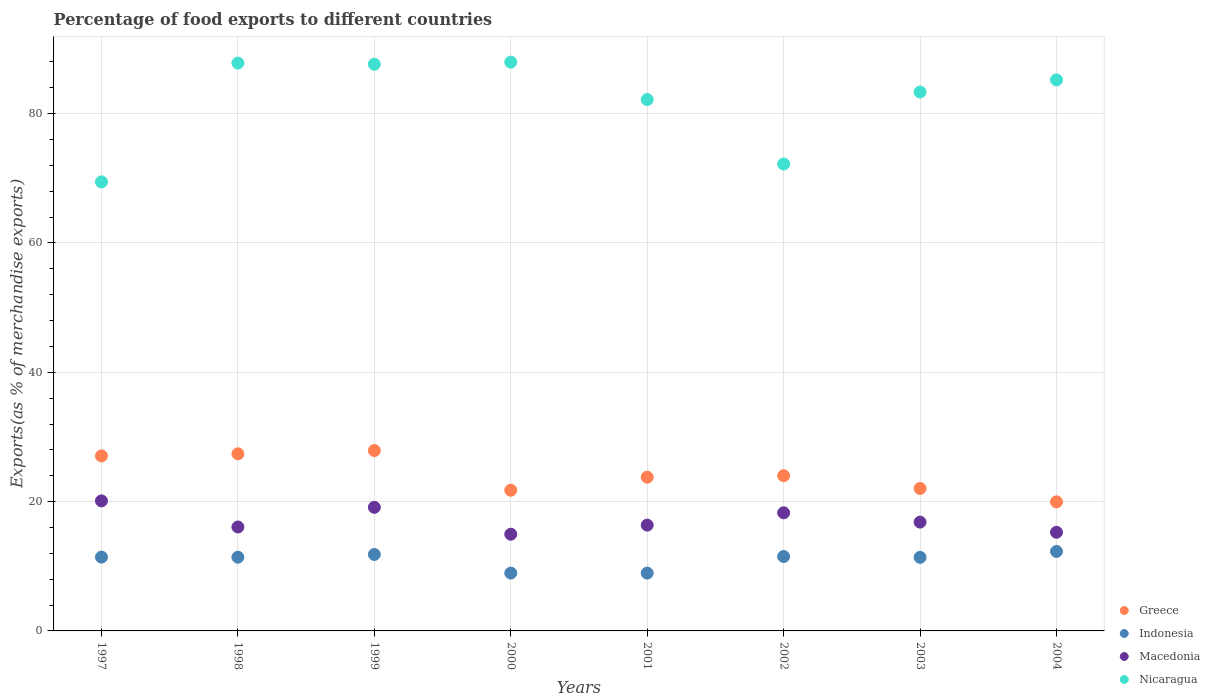How many different coloured dotlines are there?
Offer a terse response. 4. What is the percentage of exports to different countries in Indonesia in 2002?
Make the answer very short. 11.51. Across all years, what is the maximum percentage of exports to different countries in Indonesia?
Give a very brief answer. 12.29. Across all years, what is the minimum percentage of exports to different countries in Macedonia?
Your answer should be very brief. 14.96. In which year was the percentage of exports to different countries in Greece minimum?
Ensure brevity in your answer.  2004. What is the total percentage of exports to different countries in Indonesia in the graph?
Provide a short and direct response. 87.72. What is the difference between the percentage of exports to different countries in Nicaragua in 1997 and that in 2000?
Offer a very short reply. -18.52. What is the difference between the percentage of exports to different countries in Indonesia in 2002 and the percentage of exports to different countries in Greece in 2001?
Offer a terse response. -12.27. What is the average percentage of exports to different countries in Indonesia per year?
Ensure brevity in your answer.  10.97. In the year 1997, what is the difference between the percentage of exports to different countries in Nicaragua and percentage of exports to different countries in Macedonia?
Make the answer very short. 49.34. In how many years, is the percentage of exports to different countries in Indonesia greater than 16 %?
Your answer should be compact. 0. What is the ratio of the percentage of exports to different countries in Nicaragua in 1999 to that in 2003?
Your response must be concise. 1.05. Is the percentage of exports to different countries in Nicaragua in 1999 less than that in 2002?
Offer a terse response. No. Is the difference between the percentage of exports to different countries in Nicaragua in 2000 and 2003 greater than the difference between the percentage of exports to different countries in Macedonia in 2000 and 2003?
Offer a very short reply. Yes. What is the difference between the highest and the second highest percentage of exports to different countries in Indonesia?
Your answer should be compact. 0.46. What is the difference between the highest and the lowest percentage of exports to different countries in Greece?
Make the answer very short. 7.93. Is it the case that in every year, the sum of the percentage of exports to different countries in Macedonia and percentage of exports to different countries in Nicaragua  is greater than the percentage of exports to different countries in Greece?
Your answer should be compact. Yes. How many years are there in the graph?
Your answer should be compact. 8. What is the difference between two consecutive major ticks on the Y-axis?
Make the answer very short. 20. Are the values on the major ticks of Y-axis written in scientific E-notation?
Your response must be concise. No. Does the graph contain any zero values?
Offer a very short reply. No. Does the graph contain grids?
Ensure brevity in your answer.  Yes. How many legend labels are there?
Keep it short and to the point. 4. What is the title of the graph?
Your answer should be compact. Percentage of food exports to different countries. Does "Cameroon" appear as one of the legend labels in the graph?
Make the answer very short. No. What is the label or title of the Y-axis?
Provide a short and direct response. Exports(as % of merchandise exports). What is the Exports(as % of merchandise exports) in Greece in 1997?
Provide a short and direct response. 27.07. What is the Exports(as % of merchandise exports) of Indonesia in 1997?
Your answer should be very brief. 11.42. What is the Exports(as % of merchandise exports) of Macedonia in 1997?
Ensure brevity in your answer.  20.11. What is the Exports(as % of merchandise exports) of Nicaragua in 1997?
Give a very brief answer. 69.45. What is the Exports(as % of merchandise exports) of Greece in 1998?
Provide a succinct answer. 27.4. What is the Exports(as % of merchandise exports) of Indonesia in 1998?
Your response must be concise. 11.4. What is the Exports(as % of merchandise exports) of Macedonia in 1998?
Offer a terse response. 16.08. What is the Exports(as % of merchandise exports) in Nicaragua in 1998?
Ensure brevity in your answer.  87.83. What is the Exports(as % of merchandise exports) of Greece in 1999?
Offer a very short reply. 27.9. What is the Exports(as % of merchandise exports) in Indonesia in 1999?
Keep it short and to the point. 11.83. What is the Exports(as % of merchandise exports) of Macedonia in 1999?
Ensure brevity in your answer.  19.12. What is the Exports(as % of merchandise exports) in Nicaragua in 1999?
Provide a succinct answer. 87.65. What is the Exports(as % of merchandise exports) in Greece in 2000?
Give a very brief answer. 21.76. What is the Exports(as % of merchandise exports) of Indonesia in 2000?
Provide a short and direct response. 8.95. What is the Exports(as % of merchandise exports) of Macedonia in 2000?
Make the answer very short. 14.96. What is the Exports(as % of merchandise exports) of Nicaragua in 2000?
Offer a very short reply. 87.98. What is the Exports(as % of merchandise exports) in Greece in 2001?
Offer a very short reply. 23.78. What is the Exports(as % of merchandise exports) of Indonesia in 2001?
Offer a very short reply. 8.95. What is the Exports(as % of merchandise exports) in Macedonia in 2001?
Your response must be concise. 16.37. What is the Exports(as % of merchandise exports) of Nicaragua in 2001?
Offer a terse response. 82.19. What is the Exports(as % of merchandise exports) of Greece in 2002?
Your answer should be compact. 24.01. What is the Exports(as % of merchandise exports) in Indonesia in 2002?
Make the answer very short. 11.51. What is the Exports(as % of merchandise exports) in Macedonia in 2002?
Your response must be concise. 18.27. What is the Exports(as % of merchandise exports) in Nicaragua in 2002?
Offer a very short reply. 72.21. What is the Exports(as % of merchandise exports) in Greece in 2003?
Your answer should be compact. 22.03. What is the Exports(as % of merchandise exports) in Indonesia in 2003?
Provide a succinct answer. 11.38. What is the Exports(as % of merchandise exports) in Macedonia in 2003?
Make the answer very short. 16.83. What is the Exports(as % of merchandise exports) of Nicaragua in 2003?
Give a very brief answer. 83.35. What is the Exports(as % of merchandise exports) of Greece in 2004?
Provide a short and direct response. 19.96. What is the Exports(as % of merchandise exports) in Indonesia in 2004?
Give a very brief answer. 12.29. What is the Exports(as % of merchandise exports) of Macedonia in 2004?
Your answer should be compact. 15.26. What is the Exports(as % of merchandise exports) of Nicaragua in 2004?
Make the answer very short. 85.23. Across all years, what is the maximum Exports(as % of merchandise exports) of Greece?
Offer a terse response. 27.9. Across all years, what is the maximum Exports(as % of merchandise exports) of Indonesia?
Your answer should be very brief. 12.29. Across all years, what is the maximum Exports(as % of merchandise exports) in Macedonia?
Your answer should be very brief. 20.11. Across all years, what is the maximum Exports(as % of merchandise exports) in Nicaragua?
Give a very brief answer. 87.98. Across all years, what is the minimum Exports(as % of merchandise exports) in Greece?
Provide a short and direct response. 19.96. Across all years, what is the minimum Exports(as % of merchandise exports) of Indonesia?
Make the answer very short. 8.95. Across all years, what is the minimum Exports(as % of merchandise exports) of Macedonia?
Your response must be concise. 14.96. Across all years, what is the minimum Exports(as % of merchandise exports) in Nicaragua?
Provide a succinct answer. 69.45. What is the total Exports(as % of merchandise exports) of Greece in the graph?
Give a very brief answer. 193.91. What is the total Exports(as % of merchandise exports) of Indonesia in the graph?
Keep it short and to the point. 87.72. What is the total Exports(as % of merchandise exports) of Macedonia in the graph?
Give a very brief answer. 136.99. What is the total Exports(as % of merchandise exports) of Nicaragua in the graph?
Give a very brief answer. 655.89. What is the difference between the Exports(as % of merchandise exports) of Greece in 1997 and that in 1998?
Offer a very short reply. -0.33. What is the difference between the Exports(as % of merchandise exports) in Indonesia in 1997 and that in 1998?
Make the answer very short. 0.01. What is the difference between the Exports(as % of merchandise exports) of Macedonia in 1997 and that in 1998?
Offer a terse response. 4.04. What is the difference between the Exports(as % of merchandise exports) in Nicaragua in 1997 and that in 1998?
Give a very brief answer. -18.38. What is the difference between the Exports(as % of merchandise exports) in Greece in 1997 and that in 1999?
Your answer should be compact. -0.83. What is the difference between the Exports(as % of merchandise exports) of Indonesia in 1997 and that in 1999?
Your answer should be compact. -0.41. What is the difference between the Exports(as % of merchandise exports) in Nicaragua in 1997 and that in 1999?
Keep it short and to the point. -18.2. What is the difference between the Exports(as % of merchandise exports) of Greece in 1997 and that in 2000?
Give a very brief answer. 5.3. What is the difference between the Exports(as % of merchandise exports) of Indonesia in 1997 and that in 2000?
Offer a terse response. 2.47. What is the difference between the Exports(as % of merchandise exports) in Macedonia in 1997 and that in 2000?
Your answer should be compact. 5.15. What is the difference between the Exports(as % of merchandise exports) of Nicaragua in 1997 and that in 2000?
Make the answer very short. -18.52. What is the difference between the Exports(as % of merchandise exports) of Greece in 1997 and that in 2001?
Your answer should be compact. 3.29. What is the difference between the Exports(as % of merchandise exports) of Indonesia in 1997 and that in 2001?
Keep it short and to the point. 2.47. What is the difference between the Exports(as % of merchandise exports) in Macedonia in 1997 and that in 2001?
Offer a very short reply. 3.75. What is the difference between the Exports(as % of merchandise exports) in Nicaragua in 1997 and that in 2001?
Give a very brief answer. -12.73. What is the difference between the Exports(as % of merchandise exports) of Greece in 1997 and that in 2002?
Make the answer very short. 3.06. What is the difference between the Exports(as % of merchandise exports) in Indonesia in 1997 and that in 2002?
Your answer should be very brief. -0.09. What is the difference between the Exports(as % of merchandise exports) of Macedonia in 1997 and that in 2002?
Give a very brief answer. 1.84. What is the difference between the Exports(as % of merchandise exports) of Nicaragua in 1997 and that in 2002?
Your answer should be compact. -2.76. What is the difference between the Exports(as % of merchandise exports) in Greece in 1997 and that in 2003?
Your response must be concise. 5.03. What is the difference between the Exports(as % of merchandise exports) in Indonesia in 1997 and that in 2003?
Your response must be concise. 0.04. What is the difference between the Exports(as % of merchandise exports) in Macedonia in 1997 and that in 2003?
Give a very brief answer. 3.28. What is the difference between the Exports(as % of merchandise exports) in Nicaragua in 1997 and that in 2003?
Offer a terse response. -13.9. What is the difference between the Exports(as % of merchandise exports) of Greece in 1997 and that in 2004?
Your answer should be compact. 7.1. What is the difference between the Exports(as % of merchandise exports) in Indonesia in 1997 and that in 2004?
Give a very brief answer. -0.87. What is the difference between the Exports(as % of merchandise exports) of Macedonia in 1997 and that in 2004?
Your response must be concise. 4.85. What is the difference between the Exports(as % of merchandise exports) in Nicaragua in 1997 and that in 2004?
Offer a very short reply. -15.78. What is the difference between the Exports(as % of merchandise exports) in Greece in 1998 and that in 1999?
Make the answer very short. -0.5. What is the difference between the Exports(as % of merchandise exports) in Indonesia in 1998 and that in 1999?
Provide a succinct answer. -0.43. What is the difference between the Exports(as % of merchandise exports) in Macedonia in 1998 and that in 1999?
Ensure brevity in your answer.  -3.04. What is the difference between the Exports(as % of merchandise exports) in Nicaragua in 1998 and that in 1999?
Ensure brevity in your answer.  0.18. What is the difference between the Exports(as % of merchandise exports) of Greece in 1998 and that in 2000?
Your answer should be compact. 5.63. What is the difference between the Exports(as % of merchandise exports) of Indonesia in 1998 and that in 2000?
Offer a very short reply. 2.46. What is the difference between the Exports(as % of merchandise exports) in Macedonia in 1998 and that in 2000?
Offer a very short reply. 1.12. What is the difference between the Exports(as % of merchandise exports) of Nicaragua in 1998 and that in 2000?
Offer a very short reply. -0.14. What is the difference between the Exports(as % of merchandise exports) of Greece in 1998 and that in 2001?
Ensure brevity in your answer.  3.62. What is the difference between the Exports(as % of merchandise exports) of Indonesia in 1998 and that in 2001?
Offer a very short reply. 2.46. What is the difference between the Exports(as % of merchandise exports) of Macedonia in 1998 and that in 2001?
Provide a short and direct response. -0.29. What is the difference between the Exports(as % of merchandise exports) of Nicaragua in 1998 and that in 2001?
Keep it short and to the point. 5.65. What is the difference between the Exports(as % of merchandise exports) in Greece in 1998 and that in 2002?
Provide a short and direct response. 3.39. What is the difference between the Exports(as % of merchandise exports) in Indonesia in 1998 and that in 2002?
Ensure brevity in your answer.  -0.11. What is the difference between the Exports(as % of merchandise exports) of Macedonia in 1998 and that in 2002?
Your answer should be very brief. -2.2. What is the difference between the Exports(as % of merchandise exports) in Nicaragua in 1998 and that in 2002?
Your answer should be very brief. 15.62. What is the difference between the Exports(as % of merchandise exports) of Greece in 1998 and that in 2003?
Your response must be concise. 5.36. What is the difference between the Exports(as % of merchandise exports) in Indonesia in 1998 and that in 2003?
Provide a short and direct response. 0.02. What is the difference between the Exports(as % of merchandise exports) in Macedonia in 1998 and that in 2003?
Provide a succinct answer. -0.75. What is the difference between the Exports(as % of merchandise exports) in Nicaragua in 1998 and that in 2003?
Ensure brevity in your answer.  4.48. What is the difference between the Exports(as % of merchandise exports) of Greece in 1998 and that in 2004?
Keep it short and to the point. 7.43. What is the difference between the Exports(as % of merchandise exports) in Indonesia in 1998 and that in 2004?
Your answer should be very brief. -0.89. What is the difference between the Exports(as % of merchandise exports) in Macedonia in 1998 and that in 2004?
Your response must be concise. 0.82. What is the difference between the Exports(as % of merchandise exports) in Nicaragua in 1998 and that in 2004?
Make the answer very short. 2.6. What is the difference between the Exports(as % of merchandise exports) of Greece in 1999 and that in 2000?
Ensure brevity in your answer.  6.13. What is the difference between the Exports(as % of merchandise exports) of Indonesia in 1999 and that in 2000?
Your answer should be very brief. 2.88. What is the difference between the Exports(as % of merchandise exports) in Macedonia in 1999 and that in 2000?
Keep it short and to the point. 4.16. What is the difference between the Exports(as % of merchandise exports) of Nicaragua in 1999 and that in 2000?
Keep it short and to the point. -0.32. What is the difference between the Exports(as % of merchandise exports) in Greece in 1999 and that in 2001?
Your answer should be very brief. 4.12. What is the difference between the Exports(as % of merchandise exports) of Indonesia in 1999 and that in 2001?
Provide a short and direct response. 2.88. What is the difference between the Exports(as % of merchandise exports) in Macedonia in 1999 and that in 2001?
Offer a terse response. 2.75. What is the difference between the Exports(as % of merchandise exports) of Nicaragua in 1999 and that in 2001?
Your answer should be compact. 5.47. What is the difference between the Exports(as % of merchandise exports) of Greece in 1999 and that in 2002?
Offer a terse response. 3.89. What is the difference between the Exports(as % of merchandise exports) of Indonesia in 1999 and that in 2002?
Offer a very short reply. 0.32. What is the difference between the Exports(as % of merchandise exports) in Macedonia in 1999 and that in 2002?
Ensure brevity in your answer.  0.85. What is the difference between the Exports(as % of merchandise exports) in Nicaragua in 1999 and that in 2002?
Your answer should be compact. 15.44. What is the difference between the Exports(as % of merchandise exports) in Greece in 1999 and that in 2003?
Your answer should be compact. 5.86. What is the difference between the Exports(as % of merchandise exports) in Indonesia in 1999 and that in 2003?
Ensure brevity in your answer.  0.45. What is the difference between the Exports(as % of merchandise exports) of Macedonia in 1999 and that in 2003?
Provide a succinct answer. 2.29. What is the difference between the Exports(as % of merchandise exports) in Nicaragua in 1999 and that in 2003?
Provide a succinct answer. 4.3. What is the difference between the Exports(as % of merchandise exports) of Greece in 1999 and that in 2004?
Offer a very short reply. 7.93. What is the difference between the Exports(as % of merchandise exports) in Indonesia in 1999 and that in 2004?
Your answer should be compact. -0.46. What is the difference between the Exports(as % of merchandise exports) in Macedonia in 1999 and that in 2004?
Your response must be concise. 3.86. What is the difference between the Exports(as % of merchandise exports) in Nicaragua in 1999 and that in 2004?
Offer a terse response. 2.42. What is the difference between the Exports(as % of merchandise exports) of Greece in 2000 and that in 2001?
Ensure brevity in your answer.  -2.01. What is the difference between the Exports(as % of merchandise exports) of Indonesia in 2000 and that in 2001?
Your response must be concise. -0. What is the difference between the Exports(as % of merchandise exports) in Macedonia in 2000 and that in 2001?
Keep it short and to the point. -1.41. What is the difference between the Exports(as % of merchandise exports) of Nicaragua in 2000 and that in 2001?
Provide a short and direct response. 5.79. What is the difference between the Exports(as % of merchandise exports) of Greece in 2000 and that in 2002?
Your answer should be very brief. -2.24. What is the difference between the Exports(as % of merchandise exports) of Indonesia in 2000 and that in 2002?
Offer a very short reply. -2.56. What is the difference between the Exports(as % of merchandise exports) of Macedonia in 2000 and that in 2002?
Keep it short and to the point. -3.31. What is the difference between the Exports(as % of merchandise exports) in Nicaragua in 2000 and that in 2002?
Your response must be concise. 15.76. What is the difference between the Exports(as % of merchandise exports) in Greece in 2000 and that in 2003?
Offer a very short reply. -0.27. What is the difference between the Exports(as % of merchandise exports) of Indonesia in 2000 and that in 2003?
Offer a very short reply. -2.43. What is the difference between the Exports(as % of merchandise exports) in Macedonia in 2000 and that in 2003?
Keep it short and to the point. -1.87. What is the difference between the Exports(as % of merchandise exports) of Nicaragua in 2000 and that in 2003?
Provide a short and direct response. 4.63. What is the difference between the Exports(as % of merchandise exports) in Greece in 2000 and that in 2004?
Your answer should be very brief. 1.8. What is the difference between the Exports(as % of merchandise exports) of Indonesia in 2000 and that in 2004?
Give a very brief answer. -3.35. What is the difference between the Exports(as % of merchandise exports) in Nicaragua in 2000 and that in 2004?
Keep it short and to the point. 2.74. What is the difference between the Exports(as % of merchandise exports) in Greece in 2001 and that in 2002?
Provide a succinct answer. -0.23. What is the difference between the Exports(as % of merchandise exports) of Indonesia in 2001 and that in 2002?
Make the answer very short. -2.56. What is the difference between the Exports(as % of merchandise exports) in Macedonia in 2001 and that in 2002?
Provide a short and direct response. -1.9. What is the difference between the Exports(as % of merchandise exports) of Nicaragua in 2001 and that in 2002?
Keep it short and to the point. 9.97. What is the difference between the Exports(as % of merchandise exports) of Greece in 2001 and that in 2003?
Your answer should be very brief. 1.74. What is the difference between the Exports(as % of merchandise exports) in Indonesia in 2001 and that in 2003?
Your answer should be very brief. -2.43. What is the difference between the Exports(as % of merchandise exports) of Macedonia in 2001 and that in 2003?
Provide a succinct answer. -0.46. What is the difference between the Exports(as % of merchandise exports) of Nicaragua in 2001 and that in 2003?
Ensure brevity in your answer.  -1.16. What is the difference between the Exports(as % of merchandise exports) in Greece in 2001 and that in 2004?
Provide a short and direct response. 3.81. What is the difference between the Exports(as % of merchandise exports) in Indonesia in 2001 and that in 2004?
Give a very brief answer. -3.35. What is the difference between the Exports(as % of merchandise exports) in Macedonia in 2001 and that in 2004?
Ensure brevity in your answer.  1.11. What is the difference between the Exports(as % of merchandise exports) of Nicaragua in 2001 and that in 2004?
Keep it short and to the point. -3.04. What is the difference between the Exports(as % of merchandise exports) in Greece in 2002 and that in 2003?
Provide a succinct answer. 1.97. What is the difference between the Exports(as % of merchandise exports) of Indonesia in 2002 and that in 2003?
Offer a very short reply. 0.13. What is the difference between the Exports(as % of merchandise exports) in Macedonia in 2002 and that in 2003?
Keep it short and to the point. 1.44. What is the difference between the Exports(as % of merchandise exports) of Nicaragua in 2002 and that in 2003?
Your response must be concise. -11.14. What is the difference between the Exports(as % of merchandise exports) of Greece in 2002 and that in 2004?
Provide a short and direct response. 4.04. What is the difference between the Exports(as % of merchandise exports) of Indonesia in 2002 and that in 2004?
Your answer should be compact. -0.78. What is the difference between the Exports(as % of merchandise exports) in Macedonia in 2002 and that in 2004?
Make the answer very short. 3.01. What is the difference between the Exports(as % of merchandise exports) of Nicaragua in 2002 and that in 2004?
Ensure brevity in your answer.  -13.02. What is the difference between the Exports(as % of merchandise exports) in Greece in 2003 and that in 2004?
Make the answer very short. 2.07. What is the difference between the Exports(as % of merchandise exports) of Indonesia in 2003 and that in 2004?
Give a very brief answer. -0.91. What is the difference between the Exports(as % of merchandise exports) of Macedonia in 2003 and that in 2004?
Provide a short and direct response. 1.57. What is the difference between the Exports(as % of merchandise exports) in Nicaragua in 2003 and that in 2004?
Make the answer very short. -1.88. What is the difference between the Exports(as % of merchandise exports) in Greece in 1997 and the Exports(as % of merchandise exports) in Indonesia in 1998?
Keep it short and to the point. 15.66. What is the difference between the Exports(as % of merchandise exports) of Greece in 1997 and the Exports(as % of merchandise exports) of Macedonia in 1998?
Your answer should be compact. 10.99. What is the difference between the Exports(as % of merchandise exports) of Greece in 1997 and the Exports(as % of merchandise exports) of Nicaragua in 1998?
Keep it short and to the point. -60.77. What is the difference between the Exports(as % of merchandise exports) of Indonesia in 1997 and the Exports(as % of merchandise exports) of Macedonia in 1998?
Offer a terse response. -4.66. What is the difference between the Exports(as % of merchandise exports) of Indonesia in 1997 and the Exports(as % of merchandise exports) of Nicaragua in 1998?
Your response must be concise. -76.41. What is the difference between the Exports(as % of merchandise exports) in Macedonia in 1997 and the Exports(as % of merchandise exports) in Nicaragua in 1998?
Offer a very short reply. -67.72. What is the difference between the Exports(as % of merchandise exports) of Greece in 1997 and the Exports(as % of merchandise exports) of Indonesia in 1999?
Your answer should be very brief. 15.24. What is the difference between the Exports(as % of merchandise exports) of Greece in 1997 and the Exports(as % of merchandise exports) of Macedonia in 1999?
Keep it short and to the point. 7.95. What is the difference between the Exports(as % of merchandise exports) in Greece in 1997 and the Exports(as % of merchandise exports) in Nicaragua in 1999?
Make the answer very short. -60.59. What is the difference between the Exports(as % of merchandise exports) in Indonesia in 1997 and the Exports(as % of merchandise exports) in Macedonia in 1999?
Your answer should be compact. -7.7. What is the difference between the Exports(as % of merchandise exports) in Indonesia in 1997 and the Exports(as % of merchandise exports) in Nicaragua in 1999?
Your answer should be very brief. -76.24. What is the difference between the Exports(as % of merchandise exports) in Macedonia in 1997 and the Exports(as % of merchandise exports) in Nicaragua in 1999?
Your response must be concise. -67.54. What is the difference between the Exports(as % of merchandise exports) of Greece in 1997 and the Exports(as % of merchandise exports) of Indonesia in 2000?
Make the answer very short. 18.12. What is the difference between the Exports(as % of merchandise exports) in Greece in 1997 and the Exports(as % of merchandise exports) in Macedonia in 2000?
Your answer should be compact. 12.11. What is the difference between the Exports(as % of merchandise exports) of Greece in 1997 and the Exports(as % of merchandise exports) of Nicaragua in 2000?
Offer a terse response. -60.91. What is the difference between the Exports(as % of merchandise exports) of Indonesia in 1997 and the Exports(as % of merchandise exports) of Macedonia in 2000?
Make the answer very short. -3.54. What is the difference between the Exports(as % of merchandise exports) in Indonesia in 1997 and the Exports(as % of merchandise exports) in Nicaragua in 2000?
Ensure brevity in your answer.  -76.56. What is the difference between the Exports(as % of merchandise exports) in Macedonia in 1997 and the Exports(as % of merchandise exports) in Nicaragua in 2000?
Provide a short and direct response. -67.86. What is the difference between the Exports(as % of merchandise exports) in Greece in 1997 and the Exports(as % of merchandise exports) in Indonesia in 2001?
Your response must be concise. 18.12. What is the difference between the Exports(as % of merchandise exports) of Greece in 1997 and the Exports(as % of merchandise exports) of Macedonia in 2001?
Provide a short and direct response. 10.7. What is the difference between the Exports(as % of merchandise exports) in Greece in 1997 and the Exports(as % of merchandise exports) in Nicaragua in 2001?
Provide a succinct answer. -55.12. What is the difference between the Exports(as % of merchandise exports) in Indonesia in 1997 and the Exports(as % of merchandise exports) in Macedonia in 2001?
Ensure brevity in your answer.  -4.95. What is the difference between the Exports(as % of merchandise exports) of Indonesia in 1997 and the Exports(as % of merchandise exports) of Nicaragua in 2001?
Make the answer very short. -70.77. What is the difference between the Exports(as % of merchandise exports) of Macedonia in 1997 and the Exports(as % of merchandise exports) of Nicaragua in 2001?
Keep it short and to the point. -62.07. What is the difference between the Exports(as % of merchandise exports) in Greece in 1997 and the Exports(as % of merchandise exports) in Indonesia in 2002?
Offer a very short reply. 15.56. What is the difference between the Exports(as % of merchandise exports) of Greece in 1997 and the Exports(as % of merchandise exports) of Macedonia in 2002?
Ensure brevity in your answer.  8.79. What is the difference between the Exports(as % of merchandise exports) of Greece in 1997 and the Exports(as % of merchandise exports) of Nicaragua in 2002?
Offer a very short reply. -45.15. What is the difference between the Exports(as % of merchandise exports) of Indonesia in 1997 and the Exports(as % of merchandise exports) of Macedonia in 2002?
Give a very brief answer. -6.85. What is the difference between the Exports(as % of merchandise exports) of Indonesia in 1997 and the Exports(as % of merchandise exports) of Nicaragua in 2002?
Make the answer very short. -60.8. What is the difference between the Exports(as % of merchandise exports) of Macedonia in 1997 and the Exports(as % of merchandise exports) of Nicaragua in 2002?
Provide a succinct answer. -52.1. What is the difference between the Exports(as % of merchandise exports) of Greece in 1997 and the Exports(as % of merchandise exports) of Indonesia in 2003?
Keep it short and to the point. 15.69. What is the difference between the Exports(as % of merchandise exports) in Greece in 1997 and the Exports(as % of merchandise exports) in Macedonia in 2003?
Provide a succinct answer. 10.24. What is the difference between the Exports(as % of merchandise exports) in Greece in 1997 and the Exports(as % of merchandise exports) in Nicaragua in 2003?
Offer a terse response. -56.28. What is the difference between the Exports(as % of merchandise exports) in Indonesia in 1997 and the Exports(as % of merchandise exports) in Macedonia in 2003?
Offer a very short reply. -5.41. What is the difference between the Exports(as % of merchandise exports) in Indonesia in 1997 and the Exports(as % of merchandise exports) in Nicaragua in 2003?
Offer a very short reply. -71.93. What is the difference between the Exports(as % of merchandise exports) in Macedonia in 1997 and the Exports(as % of merchandise exports) in Nicaragua in 2003?
Give a very brief answer. -63.24. What is the difference between the Exports(as % of merchandise exports) in Greece in 1997 and the Exports(as % of merchandise exports) in Indonesia in 2004?
Give a very brief answer. 14.77. What is the difference between the Exports(as % of merchandise exports) of Greece in 1997 and the Exports(as % of merchandise exports) of Macedonia in 2004?
Make the answer very short. 11.81. What is the difference between the Exports(as % of merchandise exports) in Greece in 1997 and the Exports(as % of merchandise exports) in Nicaragua in 2004?
Make the answer very short. -58.16. What is the difference between the Exports(as % of merchandise exports) in Indonesia in 1997 and the Exports(as % of merchandise exports) in Macedonia in 2004?
Your response must be concise. -3.84. What is the difference between the Exports(as % of merchandise exports) in Indonesia in 1997 and the Exports(as % of merchandise exports) in Nicaragua in 2004?
Offer a very short reply. -73.81. What is the difference between the Exports(as % of merchandise exports) of Macedonia in 1997 and the Exports(as % of merchandise exports) of Nicaragua in 2004?
Offer a very short reply. -65.12. What is the difference between the Exports(as % of merchandise exports) in Greece in 1998 and the Exports(as % of merchandise exports) in Indonesia in 1999?
Your answer should be very brief. 15.57. What is the difference between the Exports(as % of merchandise exports) in Greece in 1998 and the Exports(as % of merchandise exports) in Macedonia in 1999?
Offer a very short reply. 8.28. What is the difference between the Exports(as % of merchandise exports) of Greece in 1998 and the Exports(as % of merchandise exports) of Nicaragua in 1999?
Make the answer very short. -60.26. What is the difference between the Exports(as % of merchandise exports) of Indonesia in 1998 and the Exports(as % of merchandise exports) of Macedonia in 1999?
Provide a succinct answer. -7.71. What is the difference between the Exports(as % of merchandise exports) of Indonesia in 1998 and the Exports(as % of merchandise exports) of Nicaragua in 1999?
Offer a very short reply. -76.25. What is the difference between the Exports(as % of merchandise exports) in Macedonia in 1998 and the Exports(as % of merchandise exports) in Nicaragua in 1999?
Provide a short and direct response. -71.58. What is the difference between the Exports(as % of merchandise exports) in Greece in 1998 and the Exports(as % of merchandise exports) in Indonesia in 2000?
Your response must be concise. 18.45. What is the difference between the Exports(as % of merchandise exports) of Greece in 1998 and the Exports(as % of merchandise exports) of Macedonia in 2000?
Your response must be concise. 12.44. What is the difference between the Exports(as % of merchandise exports) of Greece in 1998 and the Exports(as % of merchandise exports) of Nicaragua in 2000?
Provide a succinct answer. -60.58. What is the difference between the Exports(as % of merchandise exports) in Indonesia in 1998 and the Exports(as % of merchandise exports) in Macedonia in 2000?
Provide a short and direct response. -3.56. What is the difference between the Exports(as % of merchandise exports) of Indonesia in 1998 and the Exports(as % of merchandise exports) of Nicaragua in 2000?
Your response must be concise. -76.57. What is the difference between the Exports(as % of merchandise exports) in Macedonia in 1998 and the Exports(as % of merchandise exports) in Nicaragua in 2000?
Provide a short and direct response. -71.9. What is the difference between the Exports(as % of merchandise exports) in Greece in 1998 and the Exports(as % of merchandise exports) in Indonesia in 2001?
Your answer should be compact. 18.45. What is the difference between the Exports(as % of merchandise exports) of Greece in 1998 and the Exports(as % of merchandise exports) of Macedonia in 2001?
Offer a very short reply. 11.03. What is the difference between the Exports(as % of merchandise exports) in Greece in 1998 and the Exports(as % of merchandise exports) in Nicaragua in 2001?
Offer a terse response. -54.79. What is the difference between the Exports(as % of merchandise exports) in Indonesia in 1998 and the Exports(as % of merchandise exports) in Macedonia in 2001?
Your answer should be compact. -4.96. What is the difference between the Exports(as % of merchandise exports) in Indonesia in 1998 and the Exports(as % of merchandise exports) in Nicaragua in 2001?
Make the answer very short. -70.78. What is the difference between the Exports(as % of merchandise exports) of Macedonia in 1998 and the Exports(as % of merchandise exports) of Nicaragua in 2001?
Your answer should be compact. -66.11. What is the difference between the Exports(as % of merchandise exports) in Greece in 1998 and the Exports(as % of merchandise exports) in Indonesia in 2002?
Make the answer very short. 15.89. What is the difference between the Exports(as % of merchandise exports) of Greece in 1998 and the Exports(as % of merchandise exports) of Macedonia in 2002?
Keep it short and to the point. 9.13. What is the difference between the Exports(as % of merchandise exports) in Greece in 1998 and the Exports(as % of merchandise exports) in Nicaragua in 2002?
Ensure brevity in your answer.  -44.82. What is the difference between the Exports(as % of merchandise exports) of Indonesia in 1998 and the Exports(as % of merchandise exports) of Macedonia in 2002?
Your answer should be very brief. -6.87. What is the difference between the Exports(as % of merchandise exports) of Indonesia in 1998 and the Exports(as % of merchandise exports) of Nicaragua in 2002?
Give a very brief answer. -60.81. What is the difference between the Exports(as % of merchandise exports) in Macedonia in 1998 and the Exports(as % of merchandise exports) in Nicaragua in 2002?
Your response must be concise. -56.14. What is the difference between the Exports(as % of merchandise exports) of Greece in 1998 and the Exports(as % of merchandise exports) of Indonesia in 2003?
Keep it short and to the point. 16.02. What is the difference between the Exports(as % of merchandise exports) of Greece in 1998 and the Exports(as % of merchandise exports) of Macedonia in 2003?
Provide a short and direct response. 10.57. What is the difference between the Exports(as % of merchandise exports) of Greece in 1998 and the Exports(as % of merchandise exports) of Nicaragua in 2003?
Your answer should be compact. -55.95. What is the difference between the Exports(as % of merchandise exports) in Indonesia in 1998 and the Exports(as % of merchandise exports) in Macedonia in 2003?
Offer a terse response. -5.43. What is the difference between the Exports(as % of merchandise exports) of Indonesia in 1998 and the Exports(as % of merchandise exports) of Nicaragua in 2003?
Ensure brevity in your answer.  -71.95. What is the difference between the Exports(as % of merchandise exports) of Macedonia in 1998 and the Exports(as % of merchandise exports) of Nicaragua in 2003?
Keep it short and to the point. -67.27. What is the difference between the Exports(as % of merchandise exports) of Greece in 1998 and the Exports(as % of merchandise exports) of Indonesia in 2004?
Provide a succinct answer. 15.11. What is the difference between the Exports(as % of merchandise exports) in Greece in 1998 and the Exports(as % of merchandise exports) in Macedonia in 2004?
Your answer should be very brief. 12.14. What is the difference between the Exports(as % of merchandise exports) of Greece in 1998 and the Exports(as % of merchandise exports) of Nicaragua in 2004?
Your response must be concise. -57.83. What is the difference between the Exports(as % of merchandise exports) of Indonesia in 1998 and the Exports(as % of merchandise exports) of Macedonia in 2004?
Your answer should be very brief. -3.86. What is the difference between the Exports(as % of merchandise exports) of Indonesia in 1998 and the Exports(as % of merchandise exports) of Nicaragua in 2004?
Your answer should be very brief. -73.83. What is the difference between the Exports(as % of merchandise exports) of Macedonia in 1998 and the Exports(as % of merchandise exports) of Nicaragua in 2004?
Provide a succinct answer. -69.15. What is the difference between the Exports(as % of merchandise exports) in Greece in 1999 and the Exports(as % of merchandise exports) in Indonesia in 2000?
Your answer should be very brief. 18.95. What is the difference between the Exports(as % of merchandise exports) of Greece in 1999 and the Exports(as % of merchandise exports) of Macedonia in 2000?
Your response must be concise. 12.94. What is the difference between the Exports(as % of merchandise exports) of Greece in 1999 and the Exports(as % of merchandise exports) of Nicaragua in 2000?
Your answer should be compact. -60.08. What is the difference between the Exports(as % of merchandise exports) of Indonesia in 1999 and the Exports(as % of merchandise exports) of Macedonia in 2000?
Your response must be concise. -3.13. What is the difference between the Exports(as % of merchandise exports) of Indonesia in 1999 and the Exports(as % of merchandise exports) of Nicaragua in 2000?
Your answer should be compact. -76.15. What is the difference between the Exports(as % of merchandise exports) of Macedonia in 1999 and the Exports(as % of merchandise exports) of Nicaragua in 2000?
Provide a short and direct response. -68.86. What is the difference between the Exports(as % of merchandise exports) in Greece in 1999 and the Exports(as % of merchandise exports) in Indonesia in 2001?
Offer a terse response. 18.95. What is the difference between the Exports(as % of merchandise exports) in Greece in 1999 and the Exports(as % of merchandise exports) in Macedonia in 2001?
Your answer should be compact. 11.53. What is the difference between the Exports(as % of merchandise exports) of Greece in 1999 and the Exports(as % of merchandise exports) of Nicaragua in 2001?
Provide a short and direct response. -54.29. What is the difference between the Exports(as % of merchandise exports) of Indonesia in 1999 and the Exports(as % of merchandise exports) of Macedonia in 2001?
Your answer should be very brief. -4.54. What is the difference between the Exports(as % of merchandise exports) in Indonesia in 1999 and the Exports(as % of merchandise exports) in Nicaragua in 2001?
Give a very brief answer. -70.36. What is the difference between the Exports(as % of merchandise exports) of Macedonia in 1999 and the Exports(as % of merchandise exports) of Nicaragua in 2001?
Provide a succinct answer. -63.07. What is the difference between the Exports(as % of merchandise exports) in Greece in 1999 and the Exports(as % of merchandise exports) in Indonesia in 2002?
Provide a short and direct response. 16.39. What is the difference between the Exports(as % of merchandise exports) in Greece in 1999 and the Exports(as % of merchandise exports) in Macedonia in 2002?
Ensure brevity in your answer.  9.62. What is the difference between the Exports(as % of merchandise exports) of Greece in 1999 and the Exports(as % of merchandise exports) of Nicaragua in 2002?
Your answer should be very brief. -44.32. What is the difference between the Exports(as % of merchandise exports) in Indonesia in 1999 and the Exports(as % of merchandise exports) in Macedonia in 2002?
Your answer should be very brief. -6.44. What is the difference between the Exports(as % of merchandise exports) in Indonesia in 1999 and the Exports(as % of merchandise exports) in Nicaragua in 2002?
Provide a succinct answer. -60.39. What is the difference between the Exports(as % of merchandise exports) of Macedonia in 1999 and the Exports(as % of merchandise exports) of Nicaragua in 2002?
Your response must be concise. -53.1. What is the difference between the Exports(as % of merchandise exports) in Greece in 1999 and the Exports(as % of merchandise exports) in Indonesia in 2003?
Your answer should be compact. 16.52. What is the difference between the Exports(as % of merchandise exports) of Greece in 1999 and the Exports(as % of merchandise exports) of Macedonia in 2003?
Provide a short and direct response. 11.06. What is the difference between the Exports(as % of merchandise exports) of Greece in 1999 and the Exports(as % of merchandise exports) of Nicaragua in 2003?
Make the answer very short. -55.45. What is the difference between the Exports(as % of merchandise exports) of Indonesia in 1999 and the Exports(as % of merchandise exports) of Macedonia in 2003?
Make the answer very short. -5. What is the difference between the Exports(as % of merchandise exports) of Indonesia in 1999 and the Exports(as % of merchandise exports) of Nicaragua in 2003?
Your answer should be very brief. -71.52. What is the difference between the Exports(as % of merchandise exports) of Macedonia in 1999 and the Exports(as % of merchandise exports) of Nicaragua in 2003?
Provide a succinct answer. -64.23. What is the difference between the Exports(as % of merchandise exports) in Greece in 1999 and the Exports(as % of merchandise exports) in Indonesia in 2004?
Give a very brief answer. 15.6. What is the difference between the Exports(as % of merchandise exports) in Greece in 1999 and the Exports(as % of merchandise exports) in Macedonia in 2004?
Ensure brevity in your answer.  12.64. What is the difference between the Exports(as % of merchandise exports) of Greece in 1999 and the Exports(as % of merchandise exports) of Nicaragua in 2004?
Keep it short and to the point. -57.34. What is the difference between the Exports(as % of merchandise exports) of Indonesia in 1999 and the Exports(as % of merchandise exports) of Macedonia in 2004?
Your answer should be very brief. -3.43. What is the difference between the Exports(as % of merchandise exports) in Indonesia in 1999 and the Exports(as % of merchandise exports) in Nicaragua in 2004?
Ensure brevity in your answer.  -73.4. What is the difference between the Exports(as % of merchandise exports) in Macedonia in 1999 and the Exports(as % of merchandise exports) in Nicaragua in 2004?
Your answer should be very brief. -66.11. What is the difference between the Exports(as % of merchandise exports) of Greece in 2000 and the Exports(as % of merchandise exports) of Indonesia in 2001?
Your answer should be very brief. 12.82. What is the difference between the Exports(as % of merchandise exports) of Greece in 2000 and the Exports(as % of merchandise exports) of Macedonia in 2001?
Your answer should be very brief. 5.4. What is the difference between the Exports(as % of merchandise exports) in Greece in 2000 and the Exports(as % of merchandise exports) in Nicaragua in 2001?
Your answer should be very brief. -60.42. What is the difference between the Exports(as % of merchandise exports) of Indonesia in 2000 and the Exports(as % of merchandise exports) of Macedonia in 2001?
Give a very brief answer. -7.42. What is the difference between the Exports(as % of merchandise exports) of Indonesia in 2000 and the Exports(as % of merchandise exports) of Nicaragua in 2001?
Make the answer very short. -73.24. What is the difference between the Exports(as % of merchandise exports) of Macedonia in 2000 and the Exports(as % of merchandise exports) of Nicaragua in 2001?
Make the answer very short. -67.23. What is the difference between the Exports(as % of merchandise exports) of Greece in 2000 and the Exports(as % of merchandise exports) of Indonesia in 2002?
Your response must be concise. 10.26. What is the difference between the Exports(as % of merchandise exports) in Greece in 2000 and the Exports(as % of merchandise exports) in Macedonia in 2002?
Offer a very short reply. 3.49. What is the difference between the Exports(as % of merchandise exports) of Greece in 2000 and the Exports(as % of merchandise exports) of Nicaragua in 2002?
Your response must be concise. -50.45. What is the difference between the Exports(as % of merchandise exports) in Indonesia in 2000 and the Exports(as % of merchandise exports) in Macedonia in 2002?
Give a very brief answer. -9.33. What is the difference between the Exports(as % of merchandise exports) in Indonesia in 2000 and the Exports(as % of merchandise exports) in Nicaragua in 2002?
Provide a succinct answer. -63.27. What is the difference between the Exports(as % of merchandise exports) in Macedonia in 2000 and the Exports(as % of merchandise exports) in Nicaragua in 2002?
Offer a very short reply. -57.26. What is the difference between the Exports(as % of merchandise exports) in Greece in 2000 and the Exports(as % of merchandise exports) in Indonesia in 2003?
Give a very brief answer. 10.39. What is the difference between the Exports(as % of merchandise exports) of Greece in 2000 and the Exports(as % of merchandise exports) of Macedonia in 2003?
Your answer should be very brief. 4.93. What is the difference between the Exports(as % of merchandise exports) of Greece in 2000 and the Exports(as % of merchandise exports) of Nicaragua in 2003?
Ensure brevity in your answer.  -61.59. What is the difference between the Exports(as % of merchandise exports) in Indonesia in 2000 and the Exports(as % of merchandise exports) in Macedonia in 2003?
Ensure brevity in your answer.  -7.88. What is the difference between the Exports(as % of merchandise exports) in Indonesia in 2000 and the Exports(as % of merchandise exports) in Nicaragua in 2003?
Provide a succinct answer. -74.4. What is the difference between the Exports(as % of merchandise exports) of Macedonia in 2000 and the Exports(as % of merchandise exports) of Nicaragua in 2003?
Offer a very short reply. -68.39. What is the difference between the Exports(as % of merchandise exports) in Greece in 2000 and the Exports(as % of merchandise exports) in Indonesia in 2004?
Give a very brief answer. 9.47. What is the difference between the Exports(as % of merchandise exports) in Greece in 2000 and the Exports(as % of merchandise exports) in Macedonia in 2004?
Make the answer very short. 6.51. What is the difference between the Exports(as % of merchandise exports) of Greece in 2000 and the Exports(as % of merchandise exports) of Nicaragua in 2004?
Make the answer very short. -63.47. What is the difference between the Exports(as % of merchandise exports) of Indonesia in 2000 and the Exports(as % of merchandise exports) of Macedonia in 2004?
Provide a succinct answer. -6.31. What is the difference between the Exports(as % of merchandise exports) of Indonesia in 2000 and the Exports(as % of merchandise exports) of Nicaragua in 2004?
Your answer should be very brief. -76.28. What is the difference between the Exports(as % of merchandise exports) of Macedonia in 2000 and the Exports(as % of merchandise exports) of Nicaragua in 2004?
Keep it short and to the point. -70.27. What is the difference between the Exports(as % of merchandise exports) of Greece in 2001 and the Exports(as % of merchandise exports) of Indonesia in 2002?
Your answer should be very brief. 12.27. What is the difference between the Exports(as % of merchandise exports) in Greece in 2001 and the Exports(as % of merchandise exports) in Macedonia in 2002?
Offer a very short reply. 5.51. What is the difference between the Exports(as % of merchandise exports) of Greece in 2001 and the Exports(as % of merchandise exports) of Nicaragua in 2002?
Offer a terse response. -48.44. What is the difference between the Exports(as % of merchandise exports) of Indonesia in 2001 and the Exports(as % of merchandise exports) of Macedonia in 2002?
Keep it short and to the point. -9.33. What is the difference between the Exports(as % of merchandise exports) of Indonesia in 2001 and the Exports(as % of merchandise exports) of Nicaragua in 2002?
Your answer should be compact. -63.27. What is the difference between the Exports(as % of merchandise exports) of Macedonia in 2001 and the Exports(as % of merchandise exports) of Nicaragua in 2002?
Your answer should be compact. -55.85. What is the difference between the Exports(as % of merchandise exports) in Greece in 2001 and the Exports(as % of merchandise exports) in Indonesia in 2003?
Ensure brevity in your answer.  12.4. What is the difference between the Exports(as % of merchandise exports) in Greece in 2001 and the Exports(as % of merchandise exports) in Macedonia in 2003?
Your response must be concise. 6.95. What is the difference between the Exports(as % of merchandise exports) in Greece in 2001 and the Exports(as % of merchandise exports) in Nicaragua in 2003?
Offer a terse response. -59.57. What is the difference between the Exports(as % of merchandise exports) in Indonesia in 2001 and the Exports(as % of merchandise exports) in Macedonia in 2003?
Provide a short and direct response. -7.88. What is the difference between the Exports(as % of merchandise exports) in Indonesia in 2001 and the Exports(as % of merchandise exports) in Nicaragua in 2003?
Keep it short and to the point. -74.4. What is the difference between the Exports(as % of merchandise exports) in Macedonia in 2001 and the Exports(as % of merchandise exports) in Nicaragua in 2003?
Provide a succinct answer. -66.98. What is the difference between the Exports(as % of merchandise exports) of Greece in 2001 and the Exports(as % of merchandise exports) of Indonesia in 2004?
Your answer should be very brief. 11.49. What is the difference between the Exports(as % of merchandise exports) of Greece in 2001 and the Exports(as % of merchandise exports) of Macedonia in 2004?
Give a very brief answer. 8.52. What is the difference between the Exports(as % of merchandise exports) of Greece in 2001 and the Exports(as % of merchandise exports) of Nicaragua in 2004?
Ensure brevity in your answer.  -61.45. What is the difference between the Exports(as % of merchandise exports) of Indonesia in 2001 and the Exports(as % of merchandise exports) of Macedonia in 2004?
Ensure brevity in your answer.  -6.31. What is the difference between the Exports(as % of merchandise exports) in Indonesia in 2001 and the Exports(as % of merchandise exports) in Nicaragua in 2004?
Your response must be concise. -76.28. What is the difference between the Exports(as % of merchandise exports) in Macedonia in 2001 and the Exports(as % of merchandise exports) in Nicaragua in 2004?
Offer a very short reply. -68.86. What is the difference between the Exports(as % of merchandise exports) of Greece in 2002 and the Exports(as % of merchandise exports) of Indonesia in 2003?
Offer a very short reply. 12.63. What is the difference between the Exports(as % of merchandise exports) of Greece in 2002 and the Exports(as % of merchandise exports) of Macedonia in 2003?
Keep it short and to the point. 7.18. What is the difference between the Exports(as % of merchandise exports) of Greece in 2002 and the Exports(as % of merchandise exports) of Nicaragua in 2003?
Your response must be concise. -59.34. What is the difference between the Exports(as % of merchandise exports) in Indonesia in 2002 and the Exports(as % of merchandise exports) in Macedonia in 2003?
Ensure brevity in your answer.  -5.32. What is the difference between the Exports(as % of merchandise exports) of Indonesia in 2002 and the Exports(as % of merchandise exports) of Nicaragua in 2003?
Offer a very short reply. -71.84. What is the difference between the Exports(as % of merchandise exports) in Macedonia in 2002 and the Exports(as % of merchandise exports) in Nicaragua in 2003?
Offer a very short reply. -65.08. What is the difference between the Exports(as % of merchandise exports) of Greece in 2002 and the Exports(as % of merchandise exports) of Indonesia in 2004?
Give a very brief answer. 11.71. What is the difference between the Exports(as % of merchandise exports) in Greece in 2002 and the Exports(as % of merchandise exports) in Macedonia in 2004?
Give a very brief answer. 8.75. What is the difference between the Exports(as % of merchandise exports) of Greece in 2002 and the Exports(as % of merchandise exports) of Nicaragua in 2004?
Keep it short and to the point. -61.22. What is the difference between the Exports(as % of merchandise exports) in Indonesia in 2002 and the Exports(as % of merchandise exports) in Macedonia in 2004?
Make the answer very short. -3.75. What is the difference between the Exports(as % of merchandise exports) in Indonesia in 2002 and the Exports(as % of merchandise exports) in Nicaragua in 2004?
Make the answer very short. -73.72. What is the difference between the Exports(as % of merchandise exports) of Macedonia in 2002 and the Exports(as % of merchandise exports) of Nicaragua in 2004?
Keep it short and to the point. -66.96. What is the difference between the Exports(as % of merchandise exports) of Greece in 2003 and the Exports(as % of merchandise exports) of Indonesia in 2004?
Give a very brief answer. 9.74. What is the difference between the Exports(as % of merchandise exports) in Greece in 2003 and the Exports(as % of merchandise exports) in Macedonia in 2004?
Offer a terse response. 6.78. What is the difference between the Exports(as % of merchandise exports) of Greece in 2003 and the Exports(as % of merchandise exports) of Nicaragua in 2004?
Provide a succinct answer. -63.2. What is the difference between the Exports(as % of merchandise exports) of Indonesia in 2003 and the Exports(as % of merchandise exports) of Macedonia in 2004?
Keep it short and to the point. -3.88. What is the difference between the Exports(as % of merchandise exports) in Indonesia in 2003 and the Exports(as % of merchandise exports) in Nicaragua in 2004?
Offer a terse response. -73.85. What is the difference between the Exports(as % of merchandise exports) in Macedonia in 2003 and the Exports(as % of merchandise exports) in Nicaragua in 2004?
Offer a very short reply. -68.4. What is the average Exports(as % of merchandise exports) in Greece per year?
Your response must be concise. 24.24. What is the average Exports(as % of merchandise exports) of Indonesia per year?
Your answer should be very brief. 10.97. What is the average Exports(as % of merchandise exports) of Macedonia per year?
Ensure brevity in your answer.  17.12. What is the average Exports(as % of merchandise exports) in Nicaragua per year?
Make the answer very short. 81.99. In the year 1997, what is the difference between the Exports(as % of merchandise exports) of Greece and Exports(as % of merchandise exports) of Indonesia?
Offer a terse response. 15.65. In the year 1997, what is the difference between the Exports(as % of merchandise exports) of Greece and Exports(as % of merchandise exports) of Macedonia?
Offer a terse response. 6.95. In the year 1997, what is the difference between the Exports(as % of merchandise exports) in Greece and Exports(as % of merchandise exports) in Nicaragua?
Your response must be concise. -42.39. In the year 1997, what is the difference between the Exports(as % of merchandise exports) of Indonesia and Exports(as % of merchandise exports) of Macedonia?
Make the answer very short. -8.7. In the year 1997, what is the difference between the Exports(as % of merchandise exports) in Indonesia and Exports(as % of merchandise exports) in Nicaragua?
Provide a short and direct response. -58.04. In the year 1997, what is the difference between the Exports(as % of merchandise exports) of Macedonia and Exports(as % of merchandise exports) of Nicaragua?
Your answer should be very brief. -49.34. In the year 1998, what is the difference between the Exports(as % of merchandise exports) in Greece and Exports(as % of merchandise exports) in Indonesia?
Your response must be concise. 15.99. In the year 1998, what is the difference between the Exports(as % of merchandise exports) in Greece and Exports(as % of merchandise exports) in Macedonia?
Keep it short and to the point. 11.32. In the year 1998, what is the difference between the Exports(as % of merchandise exports) of Greece and Exports(as % of merchandise exports) of Nicaragua?
Ensure brevity in your answer.  -60.43. In the year 1998, what is the difference between the Exports(as % of merchandise exports) of Indonesia and Exports(as % of merchandise exports) of Macedonia?
Keep it short and to the point. -4.67. In the year 1998, what is the difference between the Exports(as % of merchandise exports) in Indonesia and Exports(as % of merchandise exports) in Nicaragua?
Keep it short and to the point. -76.43. In the year 1998, what is the difference between the Exports(as % of merchandise exports) of Macedonia and Exports(as % of merchandise exports) of Nicaragua?
Offer a very short reply. -71.76. In the year 1999, what is the difference between the Exports(as % of merchandise exports) in Greece and Exports(as % of merchandise exports) in Indonesia?
Provide a succinct answer. 16.07. In the year 1999, what is the difference between the Exports(as % of merchandise exports) in Greece and Exports(as % of merchandise exports) in Macedonia?
Offer a terse response. 8.78. In the year 1999, what is the difference between the Exports(as % of merchandise exports) in Greece and Exports(as % of merchandise exports) in Nicaragua?
Provide a short and direct response. -59.76. In the year 1999, what is the difference between the Exports(as % of merchandise exports) of Indonesia and Exports(as % of merchandise exports) of Macedonia?
Your response must be concise. -7.29. In the year 1999, what is the difference between the Exports(as % of merchandise exports) of Indonesia and Exports(as % of merchandise exports) of Nicaragua?
Offer a terse response. -75.82. In the year 1999, what is the difference between the Exports(as % of merchandise exports) in Macedonia and Exports(as % of merchandise exports) in Nicaragua?
Keep it short and to the point. -68.54. In the year 2000, what is the difference between the Exports(as % of merchandise exports) in Greece and Exports(as % of merchandise exports) in Indonesia?
Offer a very short reply. 12.82. In the year 2000, what is the difference between the Exports(as % of merchandise exports) of Greece and Exports(as % of merchandise exports) of Macedonia?
Ensure brevity in your answer.  6.81. In the year 2000, what is the difference between the Exports(as % of merchandise exports) of Greece and Exports(as % of merchandise exports) of Nicaragua?
Keep it short and to the point. -66.21. In the year 2000, what is the difference between the Exports(as % of merchandise exports) in Indonesia and Exports(as % of merchandise exports) in Macedonia?
Make the answer very short. -6.01. In the year 2000, what is the difference between the Exports(as % of merchandise exports) of Indonesia and Exports(as % of merchandise exports) of Nicaragua?
Keep it short and to the point. -79.03. In the year 2000, what is the difference between the Exports(as % of merchandise exports) in Macedonia and Exports(as % of merchandise exports) in Nicaragua?
Keep it short and to the point. -73.02. In the year 2001, what is the difference between the Exports(as % of merchandise exports) in Greece and Exports(as % of merchandise exports) in Indonesia?
Give a very brief answer. 14.83. In the year 2001, what is the difference between the Exports(as % of merchandise exports) of Greece and Exports(as % of merchandise exports) of Macedonia?
Ensure brevity in your answer.  7.41. In the year 2001, what is the difference between the Exports(as % of merchandise exports) of Greece and Exports(as % of merchandise exports) of Nicaragua?
Offer a terse response. -58.41. In the year 2001, what is the difference between the Exports(as % of merchandise exports) in Indonesia and Exports(as % of merchandise exports) in Macedonia?
Provide a short and direct response. -7.42. In the year 2001, what is the difference between the Exports(as % of merchandise exports) of Indonesia and Exports(as % of merchandise exports) of Nicaragua?
Your answer should be compact. -73.24. In the year 2001, what is the difference between the Exports(as % of merchandise exports) in Macedonia and Exports(as % of merchandise exports) in Nicaragua?
Your answer should be compact. -65.82. In the year 2002, what is the difference between the Exports(as % of merchandise exports) in Greece and Exports(as % of merchandise exports) in Indonesia?
Your answer should be compact. 12.5. In the year 2002, what is the difference between the Exports(as % of merchandise exports) of Greece and Exports(as % of merchandise exports) of Macedonia?
Ensure brevity in your answer.  5.73. In the year 2002, what is the difference between the Exports(as % of merchandise exports) in Greece and Exports(as % of merchandise exports) in Nicaragua?
Your answer should be very brief. -48.21. In the year 2002, what is the difference between the Exports(as % of merchandise exports) in Indonesia and Exports(as % of merchandise exports) in Macedonia?
Ensure brevity in your answer.  -6.76. In the year 2002, what is the difference between the Exports(as % of merchandise exports) of Indonesia and Exports(as % of merchandise exports) of Nicaragua?
Provide a short and direct response. -60.71. In the year 2002, what is the difference between the Exports(as % of merchandise exports) of Macedonia and Exports(as % of merchandise exports) of Nicaragua?
Provide a short and direct response. -53.94. In the year 2003, what is the difference between the Exports(as % of merchandise exports) in Greece and Exports(as % of merchandise exports) in Indonesia?
Your answer should be very brief. 10.66. In the year 2003, what is the difference between the Exports(as % of merchandise exports) in Greece and Exports(as % of merchandise exports) in Macedonia?
Your answer should be very brief. 5.2. In the year 2003, what is the difference between the Exports(as % of merchandise exports) of Greece and Exports(as % of merchandise exports) of Nicaragua?
Ensure brevity in your answer.  -61.31. In the year 2003, what is the difference between the Exports(as % of merchandise exports) in Indonesia and Exports(as % of merchandise exports) in Macedonia?
Offer a terse response. -5.45. In the year 2003, what is the difference between the Exports(as % of merchandise exports) in Indonesia and Exports(as % of merchandise exports) in Nicaragua?
Provide a succinct answer. -71.97. In the year 2003, what is the difference between the Exports(as % of merchandise exports) of Macedonia and Exports(as % of merchandise exports) of Nicaragua?
Your answer should be compact. -66.52. In the year 2004, what is the difference between the Exports(as % of merchandise exports) in Greece and Exports(as % of merchandise exports) in Indonesia?
Keep it short and to the point. 7.67. In the year 2004, what is the difference between the Exports(as % of merchandise exports) of Greece and Exports(as % of merchandise exports) of Macedonia?
Provide a succinct answer. 4.71. In the year 2004, what is the difference between the Exports(as % of merchandise exports) of Greece and Exports(as % of merchandise exports) of Nicaragua?
Ensure brevity in your answer.  -65.27. In the year 2004, what is the difference between the Exports(as % of merchandise exports) of Indonesia and Exports(as % of merchandise exports) of Macedonia?
Keep it short and to the point. -2.97. In the year 2004, what is the difference between the Exports(as % of merchandise exports) of Indonesia and Exports(as % of merchandise exports) of Nicaragua?
Make the answer very short. -72.94. In the year 2004, what is the difference between the Exports(as % of merchandise exports) in Macedonia and Exports(as % of merchandise exports) in Nicaragua?
Offer a very short reply. -69.97. What is the ratio of the Exports(as % of merchandise exports) in Greece in 1997 to that in 1998?
Your answer should be very brief. 0.99. What is the ratio of the Exports(as % of merchandise exports) in Macedonia in 1997 to that in 1998?
Your answer should be very brief. 1.25. What is the ratio of the Exports(as % of merchandise exports) in Nicaragua in 1997 to that in 1998?
Give a very brief answer. 0.79. What is the ratio of the Exports(as % of merchandise exports) of Greece in 1997 to that in 1999?
Provide a succinct answer. 0.97. What is the ratio of the Exports(as % of merchandise exports) of Indonesia in 1997 to that in 1999?
Give a very brief answer. 0.97. What is the ratio of the Exports(as % of merchandise exports) of Macedonia in 1997 to that in 1999?
Make the answer very short. 1.05. What is the ratio of the Exports(as % of merchandise exports) of Nicaragua in 1997 to that in 1999?
Give a very brief answer. 0.79. What is the ratio of the Exports(as % of merchandise exports) in Greece in 1997 to that in 2000?
Offer a very short reply. 1.24. What is the ratio of the Exports(as % of merchandise exports) of Indonesia in 1997 to that in 2000?
Your response must be concise. 1.28. What is the ratio of the Exports(as % of merchandise exports) in Macedonia in 1997 to that in 2000?
Keep it short and to the point. 1.34. What is the ratio of the Exports(as % of merchandise exports) of Nicaragua in 1997 to that in 2000?
Provide a short and direct response. 0.79. What is the ratio of the Exports(as % of merchandise exports) in Greece in 1997 to that in 2001?
Offer a very short reply. 1.14. What is the ratio of the Exports(as % of merchandise exports) in Indonesia in 1997 to that in 2001?
Provide a succinct answer. 1.28. What is the ratio of the Exports(as % of merchandise exports) of Macedonia in 1997 to that in 2001?
Provide a succinct answer. 1.23. What is the ratio of the Exports(as % of merchandise exports) of Nicaragua in 1997 to that in 2001?
Your response must be concise. 0.85. What is the ratio of the Exports(as % of merchandise exports) in Greece in 1997 to that in 2002?
Provide a short and direct response. 1.13. What is the ratio of the Exports(as % of merchandise exports) in Indonesia in 1997 to that in 2002?
Ensure brevity in your answer.  0.99. What is the ratio of the Exports(as % of merchandise exports) in Macedonia in 1997 to that in 2002?
Your answer should be very brief. 1.1. What is the ratio of the Exports(as % of merchandise exports) in Nicaragua in 1997 to that in 2002?
Make the answer very short. 0.96. What is the ratio of the Exports(as % of merchandise exports) in Greece in 1997 to that in 2003?
Your response must be concise. 1.23. What is the ratio of the Exports(as % of merchandise exports) of Macedonia in 1997 to that in 2003?
Your answer should be very brief. 1.2. What is the ratio of the Exports(as % of merchandise exports) of Nicaragua in 1997 to that in 2003?
Provide a short and direct response. 0.83. What is the ratio of the Exports(as % of merchandise exports) in Greece in 1997 to that in 2004?
Give a very brief answer. 1.36. What is the ratio of the Exports(as % of merchandise exports) in Indonesia in 1997 to that in 2004?
Your answer should be compact. 0.93. What is the ratio of the Exports(as % of merchandise exports) of Macedonia in 1997 to that in 2004?
Your answer should be compact. 1.32. What is the ratio of the Exports(as % of merchandise exports) in Nicaragua in 1997 to that in 2004?
Offer a very short reply. 0.81. What is the ratio of the Exports(as % of merchandise exports) in Greece in 1998 to that in 1999?
Ensure brevity in your answer.  0.98. What is the ratio of the Exports(as % of merchandise exports) in Indonesia in 1998 to that in 1999?
Provide a succinct answer. 0.96. What is the ratio of the Exports(as % of merchandise exports) in Macedonia in 1998 to that in 1999?
Your answer should be compact. 0.84. What is the ratio of the Exports(as % of merchandise exports) in Greece in 1998 to that in 2000?
Keep it short and to the point. 1.26. What is the ratio of the Exports(as % of merchandise exports) of Indonesia in 1998 to that in 2000?
Keep it short and to the point. 1.27. What is the ratio of the Exports(as % of merchandise exports) of Macedonia in 1998 to that in 2000?
Offer a very short reply. 1.07. What is the ratio of the Exports(as % of merchandise exports) of Nicaragua in 1998 to that in 2000?
Give a very brief answer. 1. What is the ratio of the Exports(as % of merchandise exports) in Greece in 1998 to that in 2001?
Offer a very short reply. 1.15. What is the ratio of the Exports(as % of merchandise exports) in Indonesia in 1998 to that in 2001?
Provide a short and direct response. 1.27. What is the ratio of the Exports(as % of merchandise exports) of Macedonia in 1998 to that in 2001?
Give a very brief answer. 0.98. What is the ratio of the Exports(as % of merchandise exports) of Nicaragua in 1998 to that in 2001?
Your answer should be very brief. 1.07. What is the ratio of the Exports(as % of merchandise exports) of Greece in 1998 to that in 2002?
Offer a very short reply. 1.14. What is the ratio of the Exports(as % of merchandise exports) of Indonesia in 1998 to that in 2002?
Ensure brevity in your answer.  0.99. What is the ratio of the Exports(as % of merchandise exports) in Macedonia in 1998 to that in 2002?
Give a very brief answer. 0.88. What is the ratio of the Exports(as % of merchandise exports) of Nicaragua in 1998 to that in 2002?
Ensure brevity in your answer.  1.22. What is the ratio of the Exports(as % of merchandise exports) in Greece in 1998 to that in 2003?
Provide a short and direct response. 1.24. What is the ratio of the Exports(as % of merchandise exports) in Macedonia in 1998 to that in 2003?
Make the answer very short. 0.96. What is the ratio of the Exports(as % of merchandise exports) in Nicaragua in 1998 to that in 2003?
Keep it short and to the point. 1.05. What is the ratio of the Exports(as % of merchandise exports) in Greece in 1998 to that in 2004?
Give a very brief answer. 1.37. What is the ratio of the Exports(as % of merchandise exports) of Indonesia in 1998 to that in 2004?
Your answer should be compact. 0.93. What is the ratio of the Exports(as % of merchandise exports) of Macedonia in 1998 to that in 2004?
Your response must be concise. 1.05. What is the ratio of the Exports(as % of merchandise exports) of Nicaragua in 1998 to that in 2004?
Give a very brief answer. 1.03. What is the ratio of the Exports(as % of merchandise exports) of Greece in 1999 to that in 2000?
Your answer should be compact. 1.28. What is the ratio of the Exports(as % of merchandise exports) of Indonesia in 1999 to that in 2000?
Offer a terse response. 1.32. What is the ratio of the Exports(as % of merchandise exports) in Macedonia in 1999 to that in 2000?
Make the answer very short. 1.28. What is the ratio of the Exports(as % of merchandise exports) in Nicaragua in 1999 to that in 2000?
Provide a succinct answer. 1. What is the ratio of the Exports(as % of merchandise exports) in Greece in 1999 to that in 2001?
Your response must be concise. 1.17. What is the ratio of the Exports(as % of merchandise exports) in Indonesia in 1999 to that in 2001?
Offer a very short reply. 1.32. What is the ratio of the Exports(as % of merchandise exports) in Macedonia in 1999 to that in 2001?
Provide a short and direct response. 1.17. What is the ratio of the Exports(as % of merchandise exports) in Nicaragua in 1999 to that in 2001?
Offer a terse response. 1.07. What is the ratio of the Exports(as % of merchandise exports) in Greece in 1999 to that in 2002?
Keep it short and to the point. 1.16. What is the ratio of the Exports(as % of merchandise exports) of Indonesia in 1999 to that in 2002?
Make the answer very short. 1.03. What is the ratio of the Exports(as % of merchandise exports) in Macedonia in 1999 to that in 2002?
Offer a terse response. 1.05. What is the ratio of the Exports(as % of merchandise exports) of Nicaragua in 1999 to that in 2002?
Make the answer very short. 1.21. What is the ratio of the Exports(as % of merchandise exports) of Greece in 1999 to that in 2003?
Your answer should be very brief. 1.27. What is the ratio of the Exports(as % of merchandise exports) in Indonesia in 1999 to that in 2003?
Offer a terse response. 1.04. What is the ratio of the Exports(as % of merchandise exports) in Macedonia in 1999 to that in 2003?
Keep it short and to the point. 1.14. What is the ratio of the Exports(as % of merchandise exports) in Nicaragua in 1999 to that in 2003?
Offer a very short reply. 1.05. What is the ratio of the Exports(as % of merchandise exports) of Greece in 1999 to that in 2004?
Keep it short and to the point. 1.4. What is the ratio of the Exports(as % of merchandise exports) of Indonesia in 1999 to that in 2004?
Your response must be concise. 0.96. What is the ratio of the Exports(as % of merchandise exports) in Macedonia in 1999 to that in 2004?
Provide a succinct answer. 1.25. What is the ratio of the Exports(as % of merchandise exports) of Nicaragua in 1999 to that in 2004?
Your answer should be very brief. 1.03. What is the ratio of the Exports(as % of merchandise exports) of Greece in 2000 to that in 2001?
Offer a terse response. 0.92. What is the ratio of the Exports(as % of merchandise exports) of Indonesia in 2000 to that in 2001?
Provide a short and direct response. 1. What is the ratio of the Exports(as % of merchandise exports) in Macedonia in 2000 to that in 2001?
Provide a succinct answer. 0.91. What is the ratio of the Exports(as % of merchandise exports) in Nicaragua in 2000 to that in 2001?
Your response must be concise. 1.07. What is the ratio of the Exports(as % of merchandise exports) in Greece in 2000 to that in 2002?
Give a very brief answer. 0.91. What is the ratio of the Exports(as % of merchandise exports) in Indonesia in 2000 to that in 2002?
Your answer should be compact. 0.78. What is the ratio of the Exports(as % of merchandise exports) of Macedonia in 2000 to that in 2002?
Make the answer very short. 0.82. What is the ratio of the Exports(as % of merchandise exports) of Nicaragua in 2000 to that in 2002?
Provide a short and direct response. 1.22. What is the ratio of the Exports(as % of merchandise exports) of Greece in 2000 to that in 2003?
Ensure brevity in your answer.  0.99. What is the ratio of the Exports(as % of merchandise exports) in Indonesia in 2000 to that in 2003?
Keep it short and to the point. 0.79. What is the ratio of the Exports(as % of merchandise exports) in Macedonia in 2000 to that in 2003?
Your response must be concise. 0.89. What is the ratio of the Exports(as % of merchandise exports) of Nicaragua in 2000 to that in 2003?
Offer a terse response. 1.06. What is the ratio of the Exports(as % of merchandise exports) in Greece in 2000 to that in 2004?
Offer a terse response. 1.09. What is the ratio of the Exports(as % of merchandise exports) in Indonesia in 2000 to that in 2004?
Provide a short and direct response. 0.73. What is the ratio of the Exports(as % of merchandise exports) in Macedonia in 2000 to that in 2004?
Provide a succinct answer. 0.98. What is the ratio of the Exports(as % of merchandise exports) in Nicaragua in 2000 to that in 2004?
Offer a terse response. 1.03. What is the ratio of the Exports(as % of merchandise exports) in Greece in 2001 to that in 2002?
Keep it short and to the point. 0.99. What is the ratio of the Exports(as % of merchandise exports) of Indonesia in 2001 to that in 2002?
Provide a succinct answer. 0.78. What is the ratio of the Exports(as % of merchandise exports) of Macedonia in 2001 to that in 2002?
Your answer should be compact. 0.9. What is the ratio of the Exports(as % of merchandise exports) of Nicaragua in 2001 to that in 2002?
Provide a short and direct response. 1.14. What is the ratio of the Exports(as % of merchandise exports) of Greece in 2001 to that in 2003?
Offer a very short reply. 1.08. What is the ratio of the Exports(as % of merchandise exports) in Indonesia in 2001 to that in 2003?
Offer a very short reply. 0.79. What is the ratio of the Exports(as % of merchandise exports) in Macedonia in 2001 to that in 2003?
Offer a very short reply. 0.97. What is the ratio of the Exports(as % of merchandise exports) in Nicaragua in 2001 to that in 2003?
Your response must be concise. 0.99. What is the ratio of the Exports(as % of merchandise exports) in Greece in 2001 to that in 2004?
Make the answer very short. 1.19. What is the ratio of the Exports(as % of merchandise exports) in Indonesia in 2001 to that in 2004?
Your response must be concise. 0.73. What is the ratio of the Exports(as % of merchandise exports) of Macedonia in 2001 to that in 2004?
Provide a succinct answer. 1.07. What is the ratio of the Exports(as % of merchandise exports) of Nicaragua in 2001 to that in 2004?
Your answer should be compact. 0.96. What is the ratio of the Exports(as % of merchandise exports) of Greece in 2002 to that in 2003?
Make the answer very short. 1.09. What is the ratio of the Exports(as % of merchandise exports) in Indonesia in 2002 to that in 2003?
Offer a very short reply. 1.01. What is the ratio of the Exports(as % of merchandise exports) in Macedonia in 2002 to that in 2003?
Your answer should be very brief. 1.09. What is the ratio of the Exports(as % of merchandise exports) of Nicaragua in 2002 to that in 2003?
Provide a succinct answer. 0.87. What is the ratio of the Exports(as % of merchandise exports) in Greece in 2002 to that in 2004?
Provide a short and direct response. 1.2. What is the ratio of the Exports(as % of merchandise exports) of Indonesia in 2002 to that in 2004?
Keep it short and to the point. 0.94. What is the ratio of the Exports(as % of merchandise exports) in Macedonia in 2002 to that in 2004?
Offer a very short reply. 1.2. What is the ratio of the Exports(as % of merchandise exports) of Nicaragua in 2002 to that in 2004?
Keep it short and to the point. 0.85. What is the ratio of the Exports(as % of merchandise exports) of Greece in 2003 to that in 2004?
Your answer should be compact. 1.1. What is the ratio of the Exports(as % of merchandise exports) in Indonesia in 2003 to that in 2004?
Provide a short and direct response. 0.93. What is the ratio of the Exports(as % of merchandise exports) of Macedonia in 2003 to that in 2004?
Offer a terse response. 1.1. What is the ratio of the Exports(as % of merchandise exports) in Nicaragua in 2003 to that in 2004?
Provide a succinct answer. 0.98. What is the difference between the highest and the second highest Exports(as % of merchandise exports) in Greece?
Offer a very short reply. 0.5. What is the difference between the highest and the second highest Exports(as % of merchandise exports) in Indonesia?
Your response must be concise. 0.46. What is the difference between the highest and the second highest Exports(as % of merchandise exports) in Nicaragua?
Give a very brief answer. 0.14. What is the difference between the highest and the lowest Exports(as % of merchandise exports) of Greece?
Provide a succinct answer. 7.93. What is the difference between the highest and the lowest Exports(as % of merchandise exports) of Indonesia?
Provide a short and direct response. 3.35. What is the difference between the highest and the lowest Exports(as % of merchandise exports) of Macedonia?
Give a very brief answer. 5.15. What is the difference between the highest and the lowest Exports(as % of merchandise exports) in Nicaragua?
Make the answer very short. 18.52. 